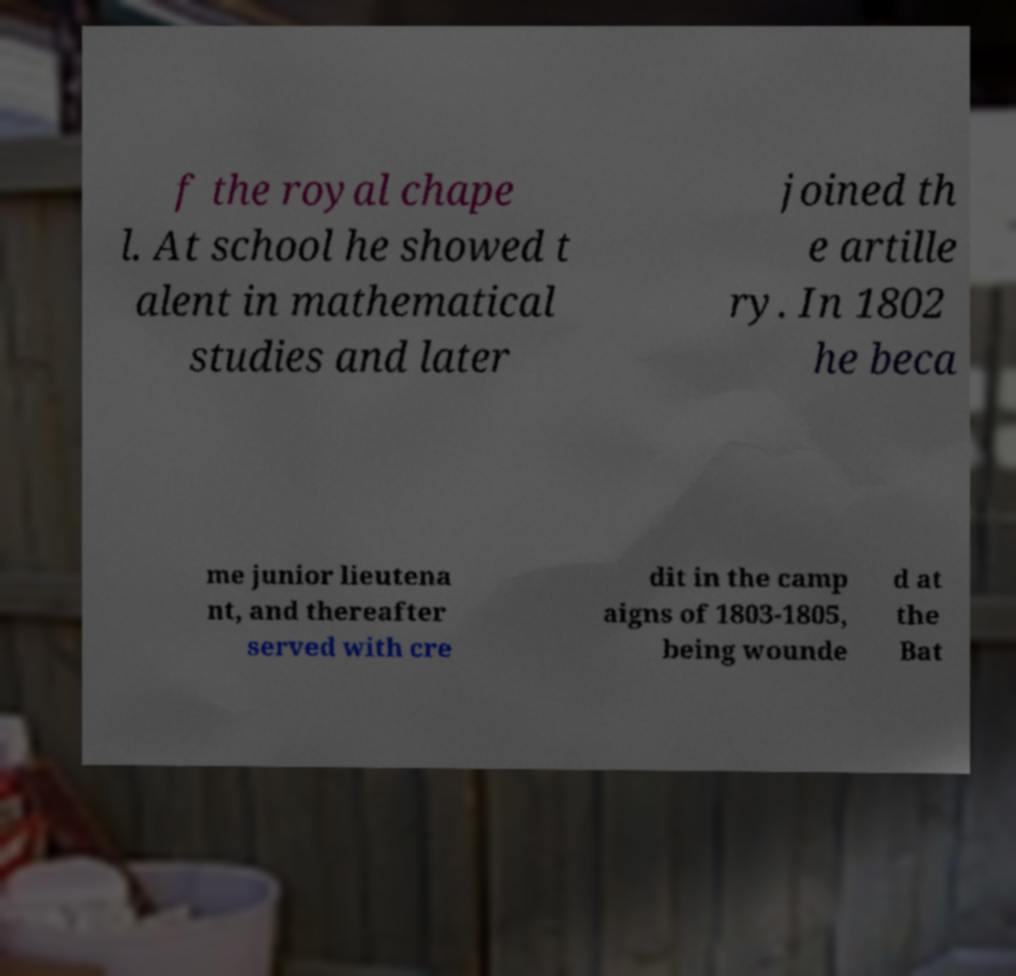For documentation purposes, I need the text within this image transcribed. Could you provide that? f the royal chape l. At school he showed t alent in mathematical studies and later joined th e artille ry. In 1802 he beca me junior lieutena nt, and thereafter served with cre dit in the camp aigns of 1803-1805, being wounde d at the Bat 